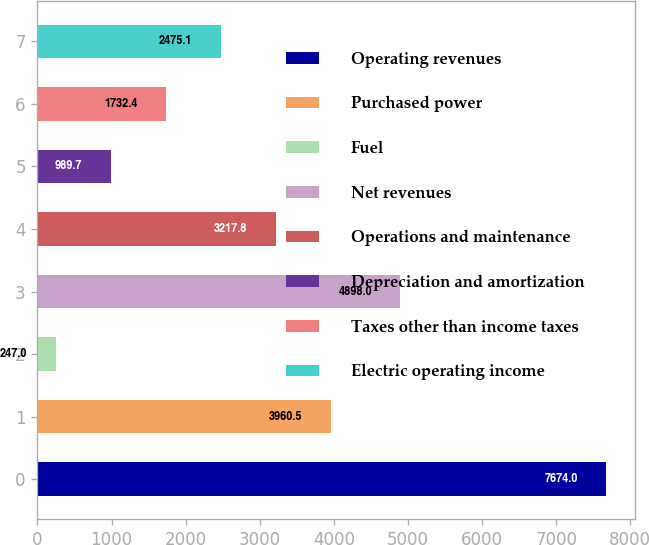<chart> <loc_0><loc_0><loc_500><loc_500><bar_chart><fcel>Operating revenues<fcel>Purchased power<fcel>Fuel<fcel>Net revenues<fcel>Operations and maintenance<fcel>Depreciation and amortization<fcel>Taxes other than income taxes<fcel>Electric operating income<nl><fcel>7674<fcel>3960.5<fcel>247<fcel>4898<fcel>3217.8<fcel>989.7<fcel>1732.4<fcel>2475.1<nl></chart> 